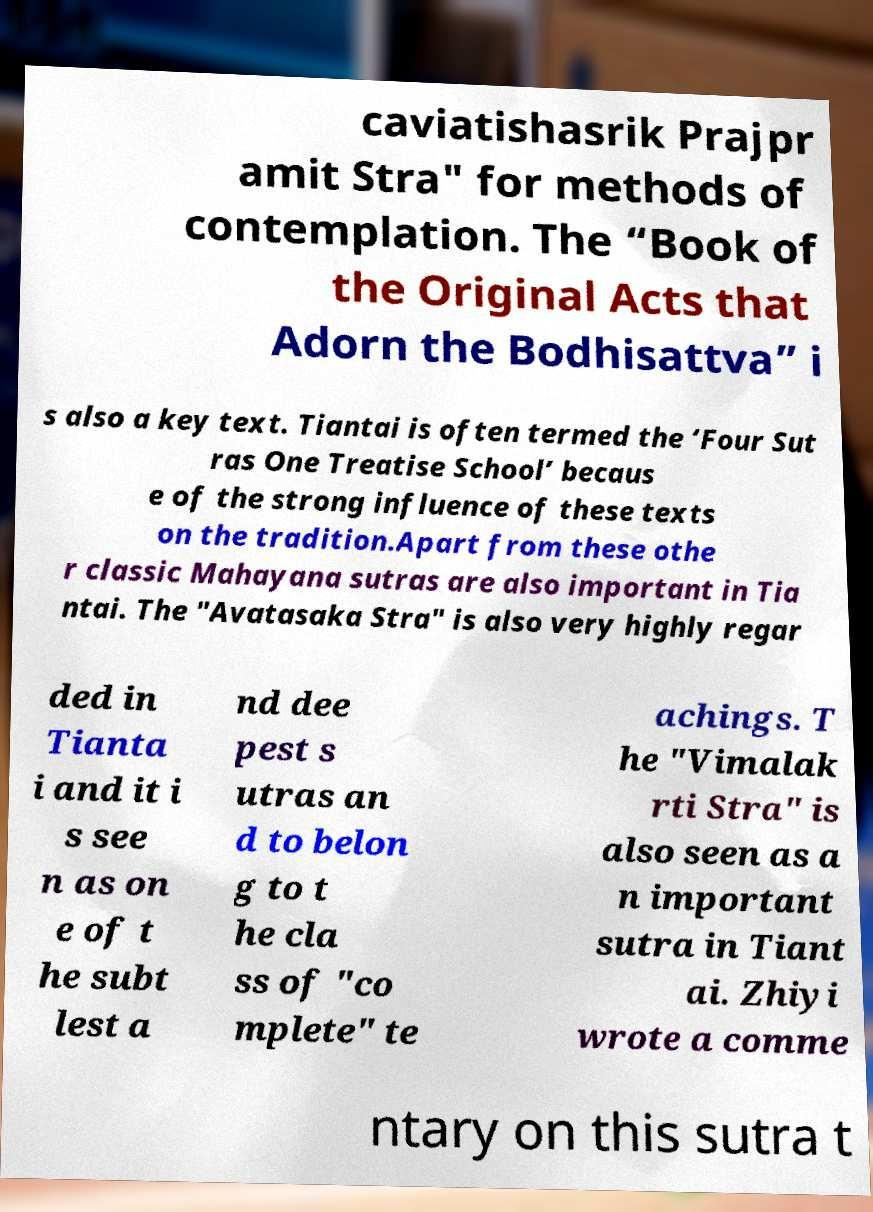For documentation purposes, I need the text within this image transcribed. Could you provide that? caviatishasrik Prajpr amit Stra" for methods of contemplation. The “Book of the Original Acts that Adorn the Bodhisattva” i s also a key text. Tiantai is often termed the ‘Four Sut ras One Treatise School’ becaus e of the strong influence of these texts on the tradition.Apart from these othe r classic Mahayana sutras are also important in Tia ntai. The "Avatasaka Stra" is also very highly regar ded in Tianta i and it i s see n as on e of t he subt lest a nd dee pest s utras an d to belon g to t he cla ss of "co mplete" te achings. T he "Vimalak rti Stra" is also seen as a n important sutra in Tiant ai. Zhiyi wrote a comme ntary on this sutra t 